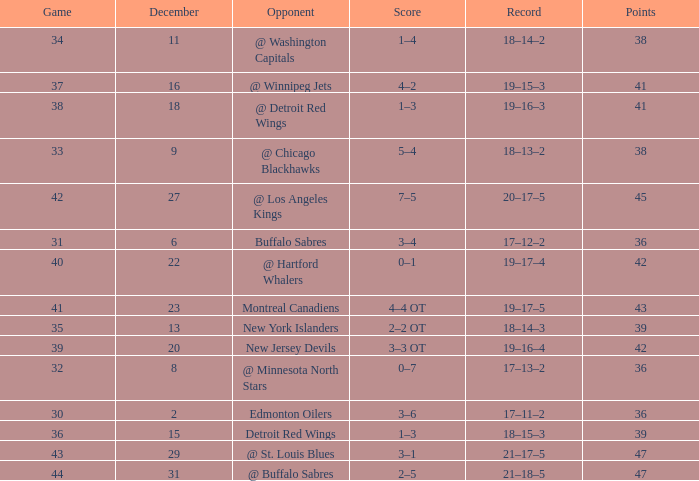After december 29 what is the score? 2–5. 